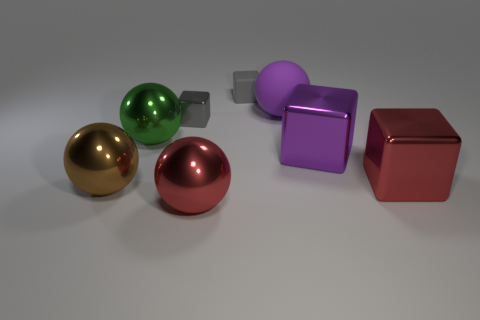Subtract 1 spheres. How many spheres are left? 3 Add 1 brown metal blocks. How many objects exist? 9 Add 2 gray metal objects. How many gray metal objects are left? 3 Add 7 red metal balls. How many red metal balls exist? 8 Subtract 1 red blocks. How many objects are left? 7 Subtract all small red rubber cylinders. Subtract all purple matte spheres. How many objects are left? 7 